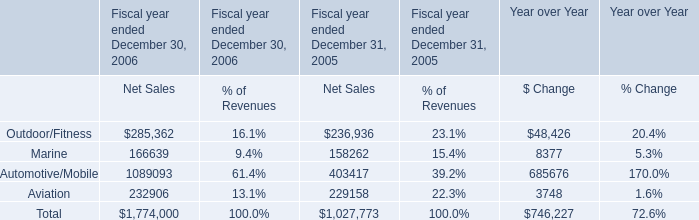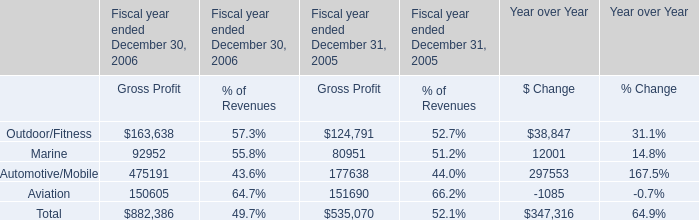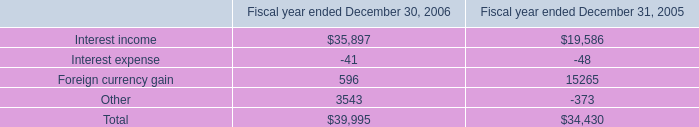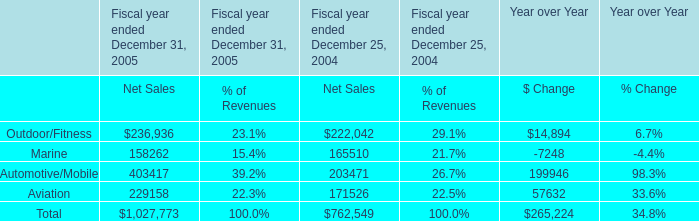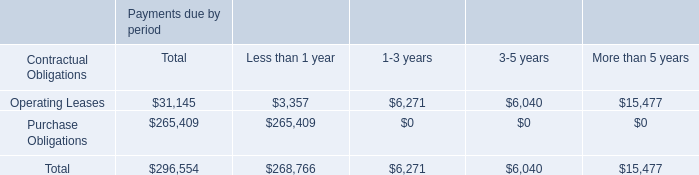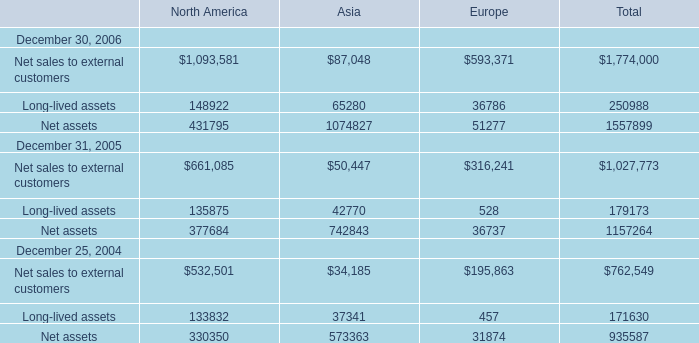As As the chart 5 shows,what's the 50 % of the Total Net assets at December 31, 2005? 
Computations: (0.5 * 1157264)
Answer: 578632.0. 